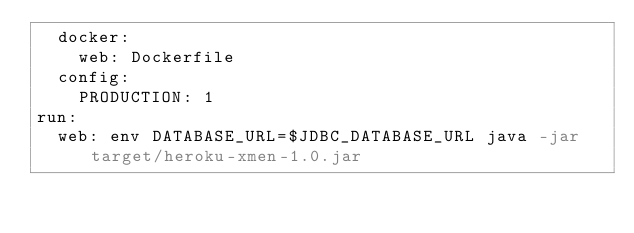Convert code to text. <code><loc_0><loc_0><loc_500><loc_500><_YAML_>  docker:
    web: Dockerfile
  config:
    PRODUCTION: 1
run:
  web: env DATABASE_URL=$JDBC_DATABASE_URL java -jar target/heroku-xmen-1.0.jar
</code> 